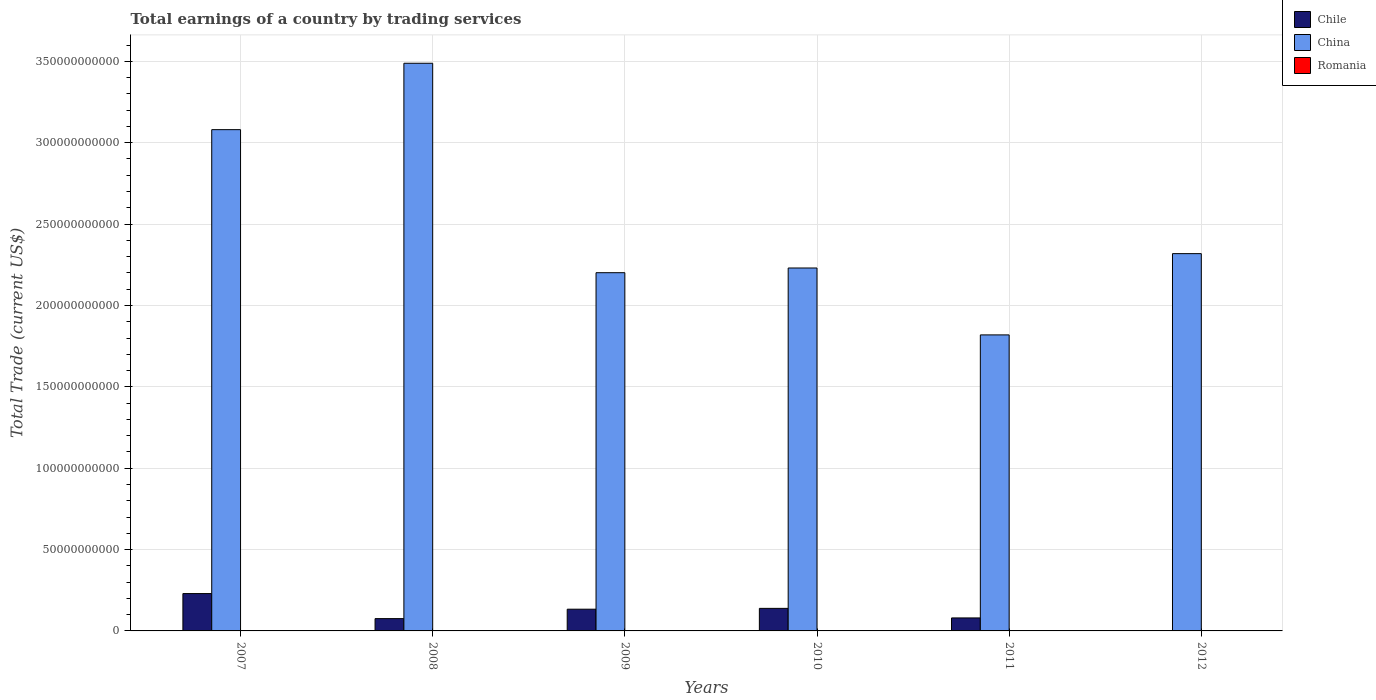How many different coloured bars are there?
Provide a succinct answer. 2. How many bars are there on the 5th tick from the right?
Your response must be concise. 2. What is the label of the 5th group of bars from the left?
Your answer should be compact. 2011. What is the total earnings in China in 2007?
Ensure brevity in your answer.  3.08e+11. Across all years, what is the maximum total earnings in China?
Ensure brevity in your answer.  3.49e+11. Across all years, what is the minimum total earnings in Romania?
Provide a succinct answer. 0. In which year was the total earnings in Chile maximum?
Offer a terse response. 2007. What is the total total earnings in China in the graph?
Your answer should be very brief. 1.51e+12. What is the difference between the total earnings in China in 2010 and that in 2012?
Give a very brief answer. -8.82e+09. What is the difference between the total earnings in Romania in 2010 and the total earnings in China in 2012?
Give a very brief answer. -2.32e+11. What is the average total earnings in China per year?
Provide a short and direct response. 2.52e+11. In the year 2008, what is the difference between the total earnings in Chile and total earnings in China?
Your answer should be compact. -3.41e+11. What is the ratio of the total earnings in China in 2011 to that in 2012?
Offer a very short reply. 0.78. Is the difference between the total earnings in Chile in 2009 and 2011 greater than the difference between the total earnings in China in 2009 and 2011?
Provide a succinct answer. No. What is the difference between the highest and the second highest total earnings in China?
Offer a very short reply. 4.08e+1. What is the difference between the highest and the lowest total earnings in Chile?
Your response must be concise. 2.30e+1. Is the sum of the total earnings in China in 2007 and 2011 greater than the maximum total earnings in Romania across all years?
Offer a terse response. Yes. Is it the case that in every year, the sum of the total earnings in China and total earnings in Chile is greater than the total earnings in Romania?
Make the answer very short. Yes. How many bars are there?
Give a very brief answer. 11. How many years are there in the graph?
Your answer should be very brief. 6. Are the values on the major ticks of Y-axis written in scientific E-notation?
Your answer should be very brief. No. Where does the legend appear in the graph?
Offer a very short reply. Top right. How many legend labels are there?
Provide a succinct answer. 3. What is the title of the graph?
Keep it short and to the point. Total earnings of a country by trading services. Does "Slovak Republic" appear as one of the legend labels in the graph?
Your response must be concise. No. What is the label or title of the X-axis?
Ensure brevity in your answer.  Years. What is the label or title of the Y-axis?
Your response must be concise. Total Trade (current US$). What is the Total Trade (current US$) in Chile in 2007?
Offer a terse response. 2.30e+1. What is the Total Trade (current US$) in China in 2007?
Your response must be concise. 3.08e+11. What is the Total Trade (current US$) in Romania in 2007?
Offer a terse response. 0. What is the Total Trade (current US$) in Chile in 2008?
Offer a very short reply. 7.56e+09. What is the Total Trade (current US$) in China in 2008?
Make the answer very short. 3.49e+11. What is the Total Trade (current US$) of Chile in 2009?
Your response must be concise. 1.33e+1. What is the Total Trade (current US$) in China in 2009?
Provide a short and direct response. 2.20e+11. What is the Total Trade (current US$) in Romania in 2009?
Give a very brief answer. 0. What is the Total Trade (current US$) of Chile in 2010?
Ensure brevity in your answer.  1.39e+1. What is the Total Trade (current US$) of China in 2010?
Your response must be concise. 2.23e+11. What is the Total Trade (current US$) in Romania in 2010?
Offer a terse response. 0. What is the Total Trade (current US$) in Chile in 2011?
Give a very brief answer. 7.99e+09. What is the Total Trade (current US$) in China in 2011?
Offer a very short reply. 1.82e+11. What is the Total Trade (current US$) of China in 2012?
Offer a terse response. 2.32e+11. What is the Total Trade (current US$) of Romania in 2012?
Ensure brevity in your answer.  0. Across all years, what is the maximum Total Trade (current US$) in Chile?
Offer a terse response. 2.30e+1. Across all years, what is the maximum Total Trade (current US$) of China?
Your answer should be very brief. 3.49e+11. Across all years, what is the minimum Total Trade (current US$) of China?
Make the answer very short. 1.82e+11. What is the total Total Trade (current US$) of Chile in the graph?
Provide a short and direct response. 6.57e+1. What is the total Total Trade (current US$) of China in the graph?
Your response must be concise. 1.51e+12. What is the difference between the Total Trade (current US$) of Chile in 2007 and that in 2008?
Make the answer very short. 1.54e+1. What is the difference between the Total Trade (current US$) of China in 2007 and that in 2008?
Your response must be concise. -4.08e+1. What is the difference between the Total Trade (current US$) of Chile in 2007 and that in 2009?
Offer a terse response. 9.60e+09. What is the difference between the Total Trade (current US$) in China in 2007 and that in 2009?
Provide a succinct answer. 8.79e+1. What is the difference between the Total Trade (current US$) in Chile in 2007 and that in 2010?
Provide a succinct answer. 9.10e+09. What is the difference between the Total Trade (current US$) of China in 2007 and that in 2010?
Make the answer very short. 8.50e+1. What is the difference between the Total Trade (current US$) in Chile in 2007 and that in 2011?
Your answer should be compact. 1.50e+1. What is the difference between the Total Trade (current US$) of China in 2007 and that in 2011?
Make the answer very short. 1.26e+11. What is the difference between the Total Trade (current US$) of China in 2007 and that in 2012?
Your answer should be compact. 7.62e+1. What is the difference between the Total Trade (current US$) in Chile in 2008 and that in 2009?
Offer a terse response. -5.78e+09. What is the difference between the Total Trade (current US$) in China in 2008 and that in 2009?
Your response must be concise. 1.29e+11. What is the difference between the Total Trade (current US$) in Chile in 2008 and that in 2010?
Offer a terse response. -6.29e+09. What is the difference between the Total Trade (current US$) of China in 2008 and that in 2010?
Provide a succinct answer. 1.26e+11. What is the difference between the Total Trade (current US$) in Chile in 2008 and that in 2011?
Provide a succinct answer. -4.22e+08. What is the difference between the Total Trade (current US$) of China in 2008 and that in 2011?
Keep it short and to the point. 1.67e+11. What is the difference between the Total Trade (current US$) of China in 2008 and that in 2012?
Make the answer very short. 1.17e+11. What is the difference between the Total Trade (current US$) in Chile in 2009 and that in 2010?
Provide a succinct answer. -5.07e+08. What is the difference between the Total Trade (current US$) of China in 2009 and that in 2010?
Offer a terse response. -2.89e+09. What is the difference between the Total Trade (current US$) of Chile in 2009 and that in 2011?
Provide a succinct answer. 5.36e+09. What is the difference between the Total Trade (current US$) in China in 2009 and that in 2011?
Your answer should be compact. 3.82e+1. What is the difference between the Total Trade (current US$) of China in 2009 and that in 2012?
Offer a very short reply. -1.17e+1. What is the difference between the Total Trade (current US$) of Chile in 2010 and that in 2011?
Keep it short and to the point. 5.87e+09. What is the difference between the Total Trade (current US$) of China in 2010 and that in 2011?
Offer a very short reply. 4.11e+1. What is the difference between the Total Trade (current US$) of China in 2010 and that in 2012?
Your answer should be compact. -8.82e+09. What is the difference between the Total Trade (current US$) in China in 2011 and that in 2012?
Keep it short and to the point. -4.99e+1. What is the difference between the Total Trade (current US$) in Chile in 2007 and the Total Trade (current US$) in China in 2008?
Offer a terse response. -3.26e+11. What is the difference between the Total Trade (current US$) of Chile in 2007 and the Total Trade (current US$) of China in 2009?
Keep it short and to the point. -1.97e+11. What is the difference between the Total Trade (current US$) of Chile in 2007 and the Total Trade (current US$) of China in 2010?
Your response must be concise. -2.00e+11. What is the difference between the Total Trade (current US$) in Chile in 2007 and the Total Trade (current US$) in China in 2011?
Offer a very short reply. -1.59e+11. What is the difference between the Total Trade (current US$) in Chile in 2007 and the Total Trade (current US$) in China in 2012?
Provide a short and direct response. -2.09e+11. What is the difference between the Total Trade (current US$) of Chile in 2008 and the Total Trade (current US$) of China in 2009?
Make the answer very short. -2.13e+11. What is the difference between the Total Trade (current US$) in Chile in 2008 and the Total Trade (current US$) in China in 2010?
Ensure brevity in your answer.  -2.15e+11. What is the difference between the Total Trade (current US$) of Chile in 2008 and the Total Trade (current US$) of China in 2011?
Ensure brevity in your answer.  -1.74e+11. What is the difference between the Total Trade (current US$) of Chile in 2008 and the Total Trade (current US$) of China in 2012?
Give a very brief answer. -2.24e+11. What is the difference between the Total Trade (current US$) in Chile in 2009 and the Total Trade (current US$) in China in 2010?
Give a very brief answer. -2.10e+11. What is the difference between the Total Trade (current US$) of Chile in 2009 and the Total Trade (current US$) of China in 2011?
Your answer should be very brief. -1.69e+11. What is the difference between the Total Trade (current US$) of Chile in 2009 and the Total Trade (current US$) of China in 2012?
Offer a very short reply. -2.18e+11. What is the difference between the Total Trade (current US$) in Chile in 2010 and the Total Trade (current US$) in China in 2011?
Your answer should be compact. -1.68e+11. What is the difference between the Total Trade (current US$) of Chile in 2010 and the Total Trade (current US$) of China in 2012?
Your answer should be compact. -2.18e+11. What is the difference between the Total Trade (current US$) in Chile in 2011 and the Total Trade (current US$) in China in 2012?
Keep it short and to the point. -2.24e+11. What is the average Total Trade (current US$) of Chile per year?
Your answer should be very brief. 1.10e+1. What is the average Total Trade (current US$) in China per year?
Keep it short and to the point. 2.52e+11. In the year 2007, what is the difference between the Total Trade (current US$) in Chile and Total Trade (current US$) in China?
Your answer should be very brief. -2.85e+11. In the year 2008, what is the difference between the Total Trade (current US$) of Chile and Total Trade (current US$) of China?
Your answer should be compact. -3.41e+11. In the year 2009, what is the difference between the Total Trade (current US$) in Chile and Total Trade (current US$) in China?
Provide a succinct answer. -2.07e+11. In the year 2010, what is the difference between the Total Trade (current US$) of Chile and Total Trade (current US$) of China?
Offer a terse response. -2.09e+11. In the year 2011, what is the difference between the Total Trade (current US$) in Chile and Total Trade (current US$) in China?
Give a very brief answer. -1.74e+11. What is the ratio of the Total Trade (current US$) in Chile in 2007 to that in 2008?
Your response must be concise. 3.03. What is the ratio of the Total Trade (current US$) of China in 2007 to that in 2008?
Your answer should be compact. 0.88. What is the ratio of the Total Trade (current US$) in Chile in 2007 to that in 2009?
Give a very brief answer. 1.72. What is the ratio of the Total Trade (current US$) of China in 2007 to that in 2009?
Provide a short and direct response. 1.4. What is the ratio of the Total Trade (current US$) in Chile in 2007 to that in 2010?
Your response must be concise. 1.66. What is the ratio of the Total Trade (current US$) of China in 2007 to that in 2010?
Ensure brevity in your answer.  1.38. What is the ratio of the Total Trade (current US$) in Chile in 2007 to that in 2011?
Make the answer very short. 2.87. What is the ratio of the Total Trade (current US$) in China in 2007 to that in 2011?
Offer a terse response. 1.69. What is the ratio of the Total Trade (current US$) of China in 2007 to that in 2012?
Keep it short and to the point. 1.33. What is the ratio of the Total Trade (current US$) of Chile in 2008 to that in 2009?
Make the answer very short. 0.57. What is the ratio of the Total Trade (current US$) in China in 2008 to that in 2009?
Offer a very short reply. 1.58. What is the ratio of the Total Trade (current US$) of Chile in 2008 to that in 2010?
Offer a very short reply. 0.55. What is the ratio of the Total Trade (current US$) in China in 2008 to that in 2010?
Offer a very short reply. 1.56. What is the ratio of the Total Trade (current US$) of Chile in 2008 to that in 2011?
Provide a short and direct response. 0.95. What is the ratio of the Total Trade (current US$) of China in 2008 to that in 2011?
Offer a very short reply. 1.92. What is the ratio of the Total Trade (current US$) in China in 2008 to that in 2012?
Your response must be concise. 1.5. What is the ratio of the Total Trade (current US$) of Chile in 2009 to that in 2010?
Your response must be concise. 0.96. What is the ratio of the Total Trade (current US$) of Chile in 2009 to that in 2011?
Your answer should be very brief. 1.67. What is the ratio of the Total Trade (current US$) of China in 2009 to that in 2011?
Offer a very short reply. 1.21. What is the ratio of the Total Trade (current US$) in China in 2009 to that in 2012?
Make the answer very short. 0.95. What is the ratio of the Total Trade (current US$) of Chile in 2010 to that in 2011?
Make the answer very short. 1.74. What is the ratio of the Total Trade (current US$) in China in 2010 to that in 2011?
Your answer should be compact. 1.23. What is the ratio of the Total Trade (current US$) in China in 2010 to that in 2012?
Offer a terse response. 0.96. What is the ratio of the Total Trade (current US$) of China in 2011 to that in 2012?
Your answer should be very brief. 0.78. What is the difference between the highest and the second highest Total Trade (current US$) of Chile?
Provide a succinct answer. 9.10e+09. What is the difference between the highest and the second highest Total Trade (current US$) in China?
Provide a succinct answer. 4.08e+1. What is the difference between the highest and the lowest Total Trade (current US$) in Chile?
Make the answer very short. 2.30e+1. What is the difference between the highest and the lowest Total Trade (current US$) of China?
Keep it short and to the point. 1.67e+11. 